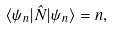Convert formula to latex. <formula><loc_0><loc_0><loc_500><loc_500>\langle \psi _ { n } | \hat { N } | \psi _ { n } \rangle = n ,</formula> 